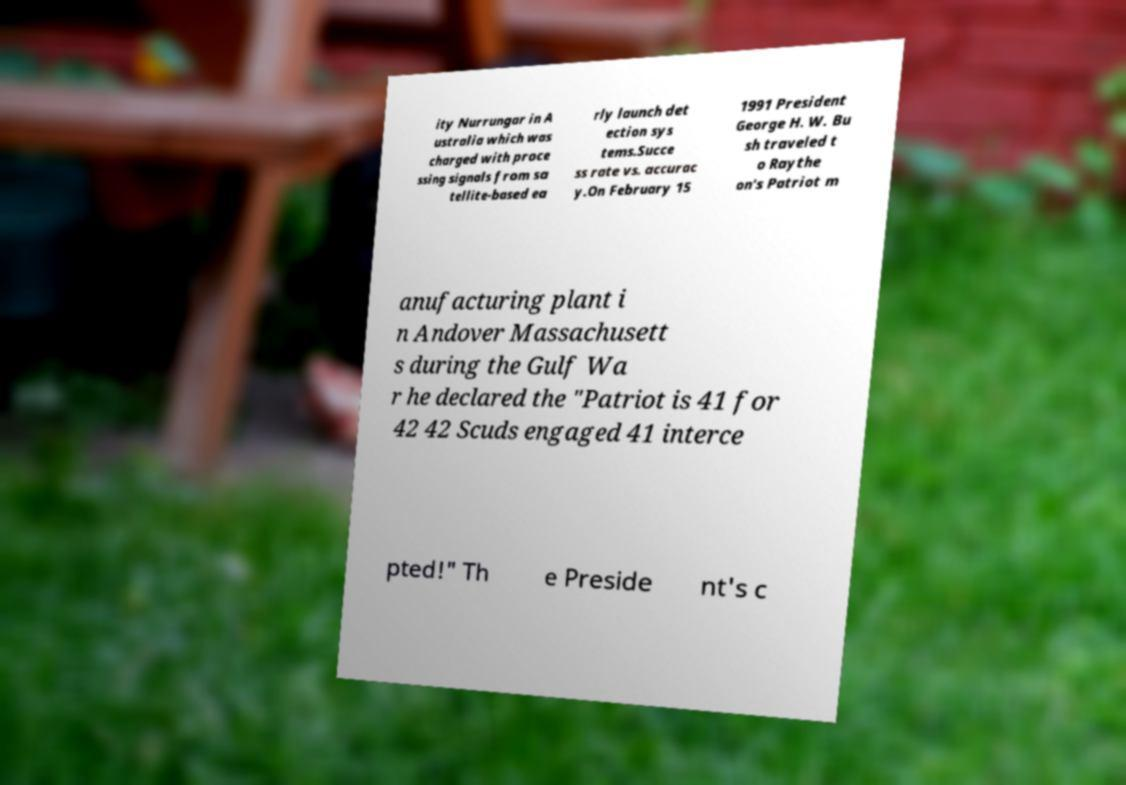What messages or text are displayed in this image? I need them in a readable, typed format. ity Nurrungar in A ustralia which was charged with proce ssing signals from sa tellite-based ea rly launch det ection sys tems.Succe ss rate vs. accurac y.On February 15 1991 President George H. W. Bu sh traveled t o Raythe on's Patriot m anufacturing plant i n Andover Massachusett s during the Gulf Wa r he declared the "Patriot is 41 for 42 42 Scuds engaged 41 interce pted!" Th e Preside nt's c 